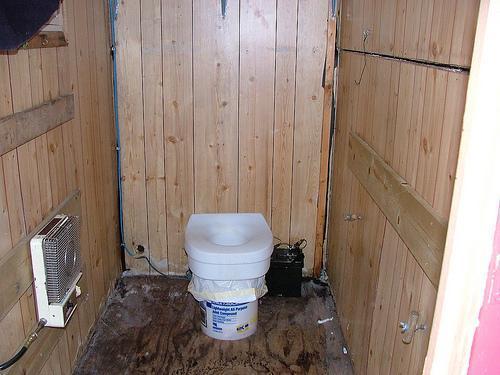How many toilet seats are there?
Give a very brief answer. 1. 